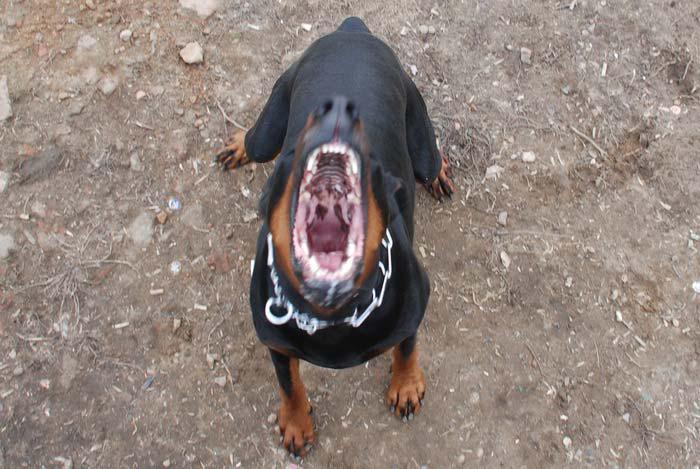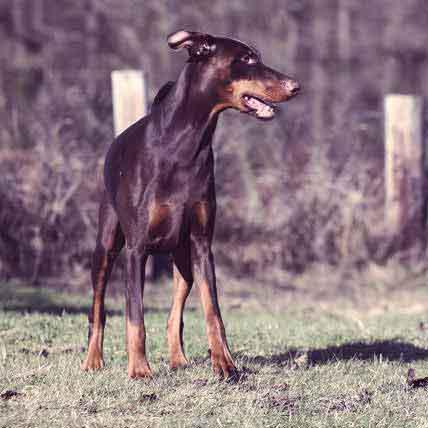The first image is the image on the left, the second image is the image on the right. Examine the images to the left and right. Is the description "All dogs shown are erect-eared dobermans gazing off to the side, and at least one dog is wearing a red collar and has a closed mouth." accurate? Answer yes or no. No. The first image is the image on the left, the second image is the image on the right. Evaluate the accuracy of this statement regarding the images: "The dog in the image on the right has its mouth open.". Is it true? Answer yes or no. Yes. 